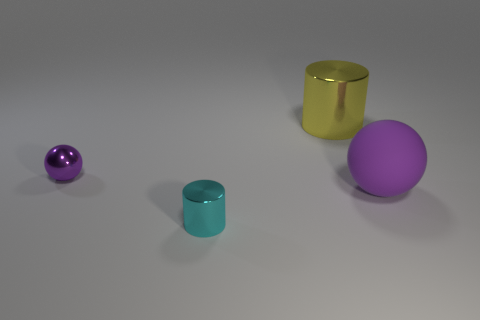What shape is the other yellow thing that is the same size as the matte thing?
Give a very brief answer. Cylinder. Are there any large objects that have the same color as the small shiny cylinder?
Your answer should be very brief. No. Is the number of yellow metal objects that are on the left side of the large yellow metallic cylinder the same as the number of metal cylinders that are in front of the cyan cylinder?
Your answer should be very brief. Yes. There is a small purple shiny object; is it the same shape as the tiny shiny object that is in front of the big purple object?
Provide a succinct answer. No. What number of other things are there of the same material as the big sphere
Your response must be concise. 0. There is a big yellow metal cylinder; are there any large spheres on the left side of it?
Offer a terse response. No. Do the yellow metal cylinder and the purple thing on the left side of the large yellow cylinder have the same size?
Give a very brief answer. No. What color is the big object on the left side of the large object in front of the big yellow cylinder?
Your answer should be compact. Yellow. Does the purple rubber sphere have the same size as the cyan object?
Keep it short and to the point. No. There is a thing that is both behind the big purple object and on the right side of the tiny purple metal ball; what is its color?
Your answer should be compact. Yellow. 